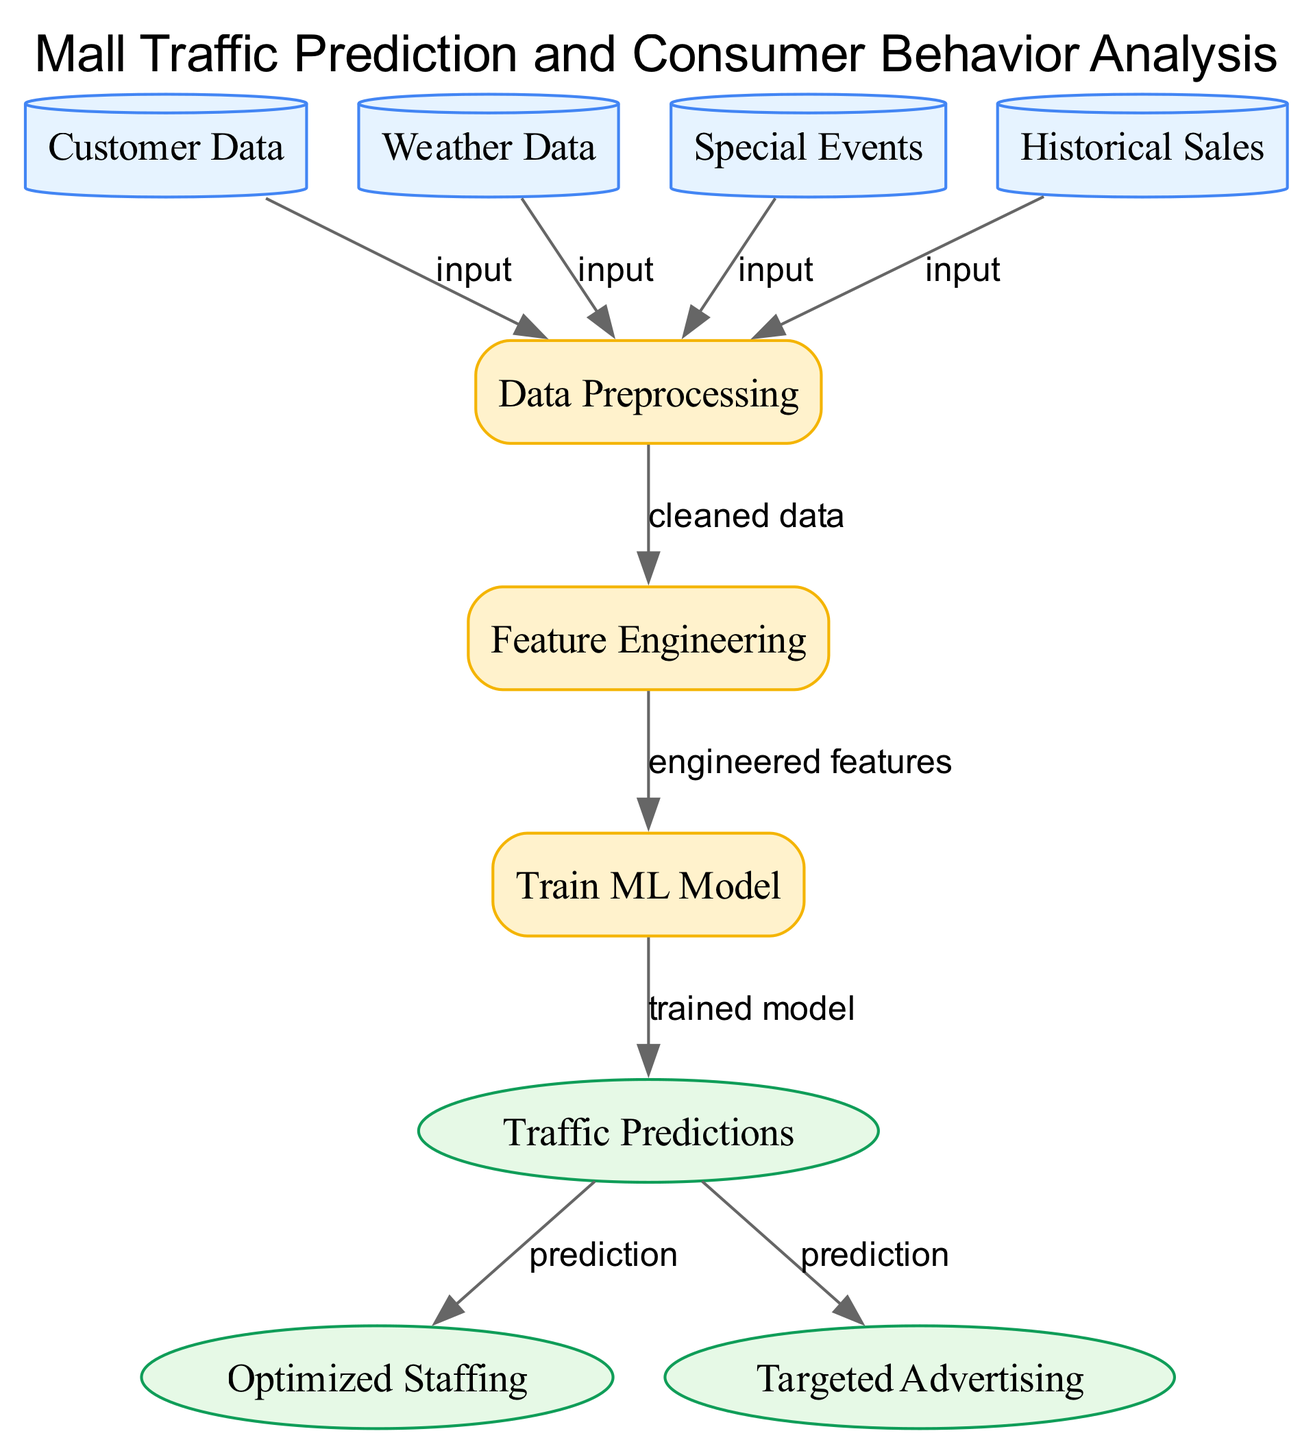What are the input nodes in the diagram? The input nodes are "Customer Data," "Weather Data," "Special Events," and "Historical Sales." These nodes represent the sources of information that feed into the data preprocessing stage.
Answer: Customer Data, Weather Data, Special Events, Historical Sales How many edges are in the diagram? The diagram has a total of 9 edges that show the relationships and flow of data between the nodes.
Answer: 9 What process follows after data preprocessing? The process that follows data preprocessing is "Feature Engineering," which takes the cleaned data and prepares it for model training.
Answer: Feature Engineering What is the final output node in the diagram? The final output nodes are "Optimized Staffing" and "Targeted Advertising," which utilize the predictions made from the traffic model.
Answer: Optimized Staffing, Targeted Advertising What data is fed into the "Train ML Model" node? The input to the "Train ML Model" node is "Engineered Features," which are the outcomes generated during the feature engineering process.
Answer: Engineered Features Which input node has the strongest impact on traffic predictions? "Special Events" likely has the strongest impact on traffic predictions, as these events can significantly change consumer behavior and shopping patterns.
Answer: Special Events How does the diagram relate traffic predictions to staffing? Traffic predictions are used to optimize staffing, meaning that the forecasted number of customers informs how many staff members are required during peak hours.
Answer: Optimized Staffing What task is performed after feature engineering? After feature engineering, the task performed is "Train ML Model," where the engineered features are used to create a predictive model.
Answer: Train ML Model What is the role of "Data Preprocessing" in the diagram? "Data Preprocessing" cleans and prepares the input data from the various sources before it undergoes feature engineering, ensuring the data is suitable for analysis.
Answer: Cleaned Data 